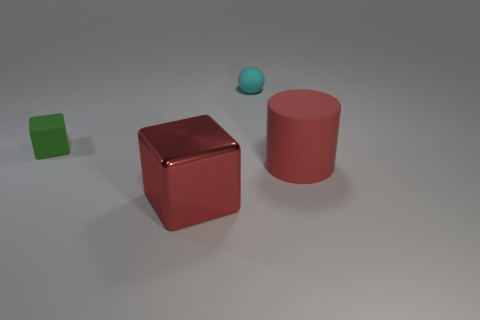There is another big object that is the same color as the large metallic object; what is its shape? cylinder 